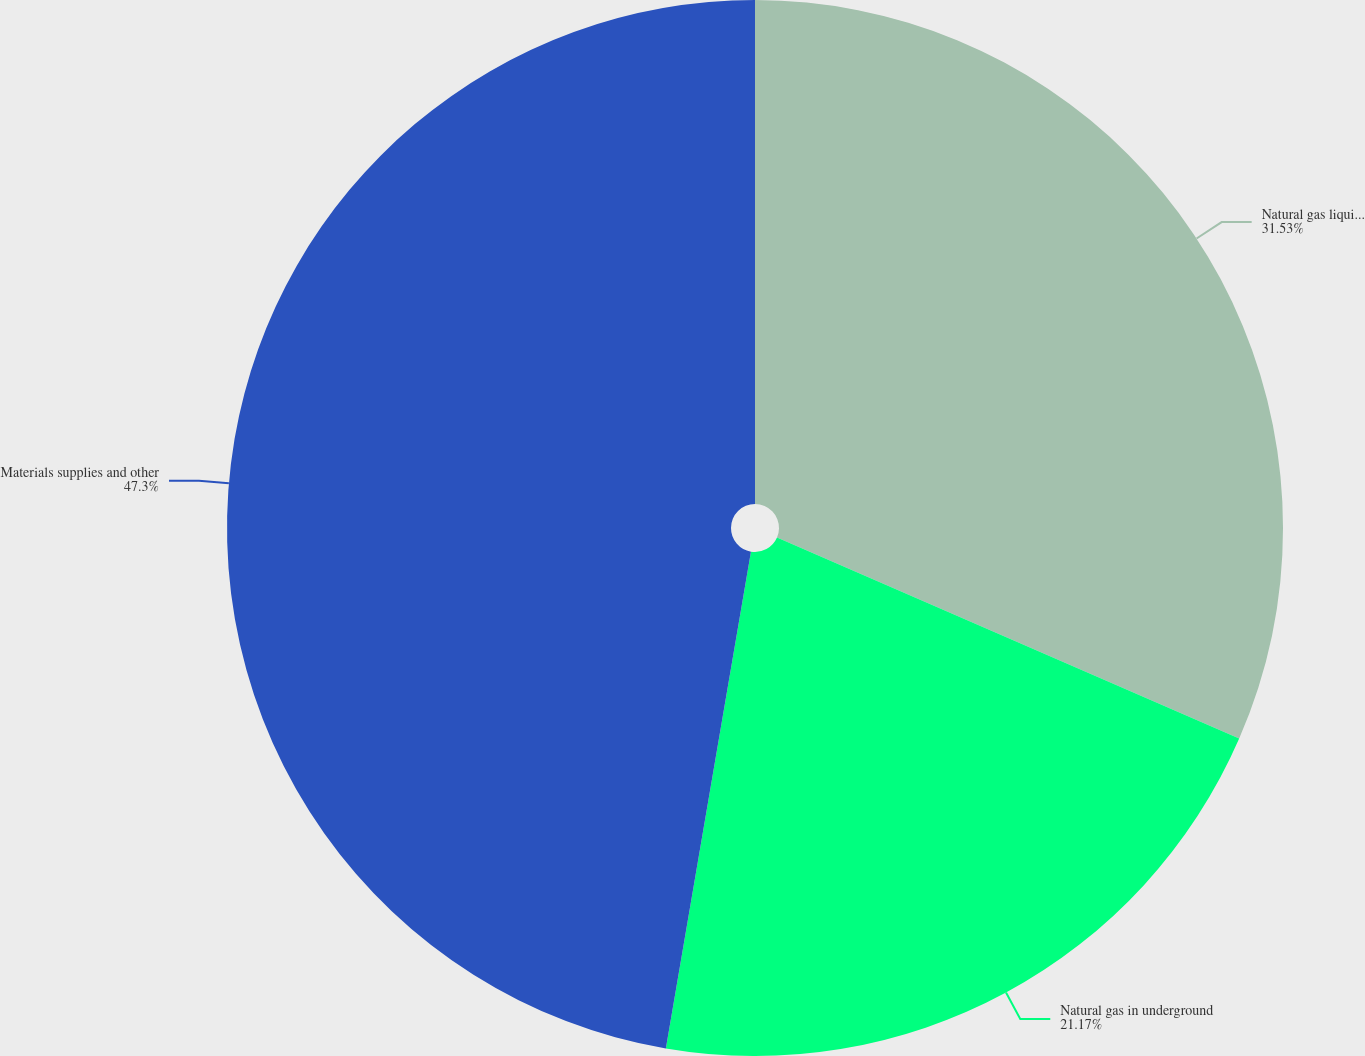Convert chart to OTSL. <chart><loc_0><loc_0><loc_500><loc_500><pie_chart><fcel>Natural gas liquids and<fcel>Natural gas in underground<fcel>Materials supplies and other<nl><fcel>31.53%<fcel>21.17%<fcel>47.3%<nl></chart> 